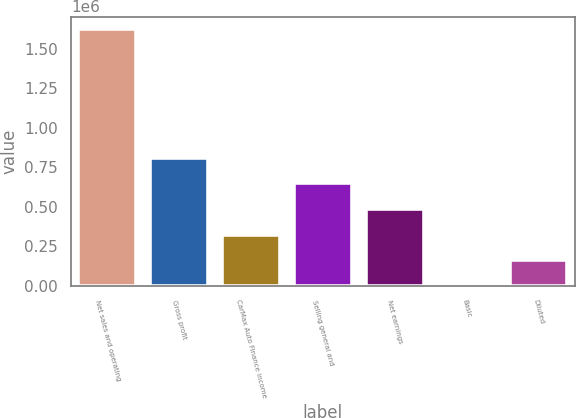<chart> <loc_0><loc_0><loc_500><loc_500><bar_chart><fcel>Net sales and operating<fcel>Gross profit<fcel>CarMax Auto Finance income<fcel>Selling general and<fcel>Net earnings<fcel>Basic<fcel>Diluted<nl><fcel>1.62377e+06<fcel>811887<fcel>324755<fcel>649510<fcel>487132<fcel>0.17<fcel>162378<nl></chart> 